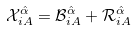<formula> <loc_0><loc_0><loc_500><loc_500>\mathcal { X } ^ { \hat { \alpha } } _ { i A } = \mathcal { B } ^ { \hat { \alpha } } _ { i A } + \mathcal { R } ^ { \hat { \alpha } } _ { i A }</formula> 